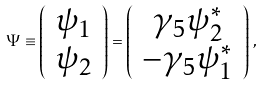Convert formula to latex. <formula><loc_0><loc_0><loc_500><loc_500>\Psi \equiv \left ( \begin{array} { c } \psi _ { 1 } \\ \psi _ { 2 } \end{array} \right ) = \left ( \begin{array} { c } \gamma _ { 5 } \psi _ { 2 } ^ { * } \\ - \gamma _ { 5 } \psi _ { 1 } ^ { * } \end{array} \right ) \, ,</formula> 